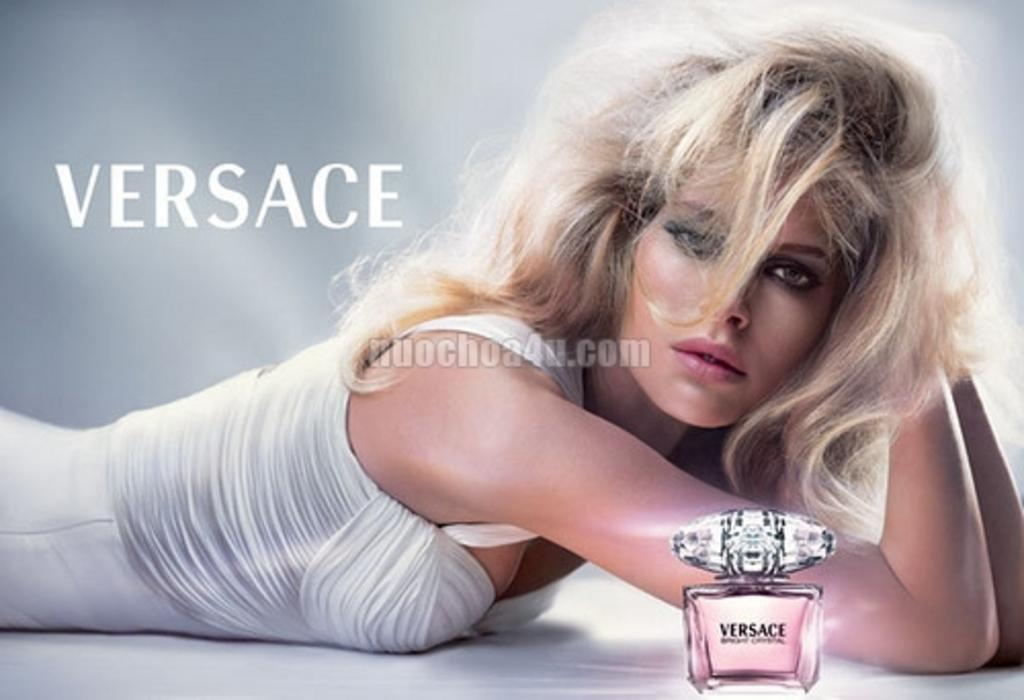<image>
Give a short and clear explanation of the subsequent image. A Versace perfum ad with a blonde model lying beside the bottle 